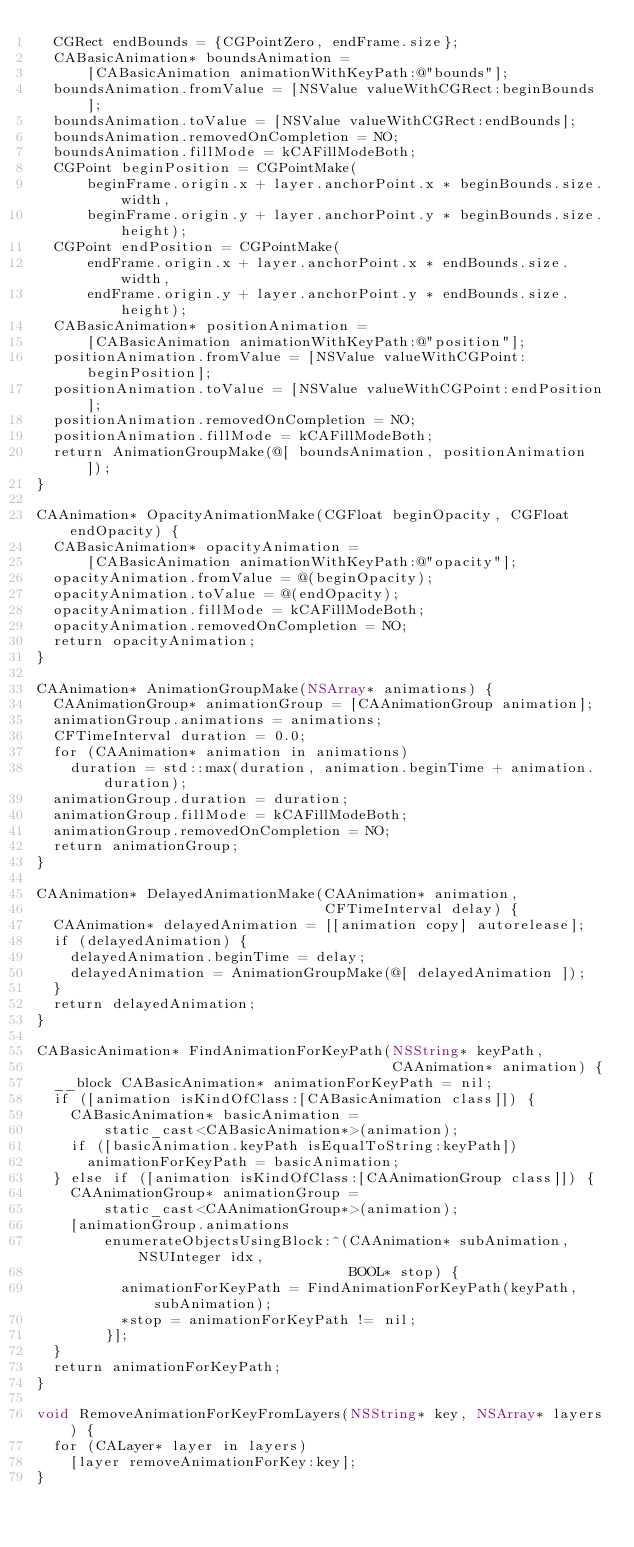<code> <loc_0><loc_0><loc_500><loc_500><_ObjectiveC_>  CGRect endBounds = {CGPointZero, endFrame.size};
  CABasicAnimation* boundsAnimation =
      [CABasicAnimation animationWithKeyPath:@"bounds"];
  boundsAnimation.fromValue = [NSValue valueWithCGRect:beginBounds];
  boundsAnimation.toValue = [NSValue valueWithCGRect:endBounds];
  boundsAnimation.removedOnCompletion = NO;
  boundsAnimation.fillMode = kCAFillModeBoth;
  CGPoint beginPosition = CGPointMake(
      beginFrame.origin.x + layer.anchorPoint.x * beginBounds.size.width,
      beginFrame.origin.y + layer.anchorPoint.y * beginBounds.size.height);
  CGPoint endPosition = CGPointMake(
      endFrame.origin.x + layer.anchorPoint.x * endBounds.size.width,
      endFrame.origin.y + layer.anchorPoint.y * endBounds.size.height);
  CABasicAnimation* positionAnimation =
      [CABasicAnimation animationWithKeyPath:@"position"];
  positionAnimation.fromValue = [NSValue valueWithCGPoint:beginPosition];
  positionAnimation.toValue = [NSValue valueWithCGPoint:endPosition];
  positionAnimation.removedOnCompletion = NO;
  positionAnimation.fillMode = kCAFillModeBoth;
  return AnimationGroupMake(@[ boundsAnimation, positionAnimation ]);
}

CAAnimation* OpacityAnimationMake(CGFloat beginOpacity, CGFloat endOpacity) {
  CABasicAnimation* opacityAnimation =
      [CABasicAnimation animationWithKeyPath:@"opacity"];
  opacityAnimation.fromValue = @(beginOpacity);
  opacityAnimation.toValue = @(endOpacity);
  opacityAnimation.fillMode = kCAFillModeBoth;
  opacityAnimation.removedOnCompletion = NO;
  return opacityAnimation;
}

CAAnimation* AnimationGroupMake(NSArray* animations) {
  CAAnimationGroup* animationGroup = [CAAnimationGroup animation];
  animationGroup.animations = animations;
  CFTimeInterval duration = 0.0;
  for (CAAnimation* animation in animations)
    duration = std::max(duration, animation.beginTime + animation.duration);
  animationGroup.duration = duration;
  animationGroup.fillMode = kCAFillModeBoth;
  animationGroup.removedOnCompletion = NO;
  return animationGroup;
}

CAAnimation* DelayedAnimationMake(CAAnimation* animation,
                                  CFTimeInterval delay) {
  CAAnimation* delayedAnimation = [[animation copy] autorelease];
  if (delayedAnimation) {
    delayedAnimation.beginTime = delay;
    delayedAnimation = AnimationGroupMake(@[ delayedAnimation ]);
  }
  return delayedAnimation;
}

CABasicAnimation* FindAnimationForKeyPath(NSString* keyPath,
                                          CAAnimation* animation) {
  __block CABasicAnimation* animationForKeyPath = nil;
  if ([animation isKindOfClass:[CABasicAnimation class]]) {
    CABasicAnimation* basicAnimation =
        static_cast<CABasicAnimation*>(animation);
    if ([basicAnimation.keyPath isEqualToString:keyPath])
      animationForKeyPath = basicAnimation;
  } else if ([animation isKindOfClass:[CAAnimationGroup class]]) {
    CAAnimationGroup* animationGroup =
        static_cast<CAAnimationGroup*>(animation);
    [animationGroup.animations
        enumerateObjectsUsingBlock:^(CAAnimation* subAnimation, NSUInteger idx,
                                     BOOL* stop) {
          animationForKeyPath = FindAnimationForKeyPath(keyPath, subAnimation);
          *stop = animationForKeyPath != nil;
        }];
  }
  return animationForKeyPath;
}

void RemoveAnimationForKeyFromLayers(NSString* key, NSArray* layers) {
  for (CALayer* layer in layers)
    [layer removeAnimationForKey:key];
}
</code> 